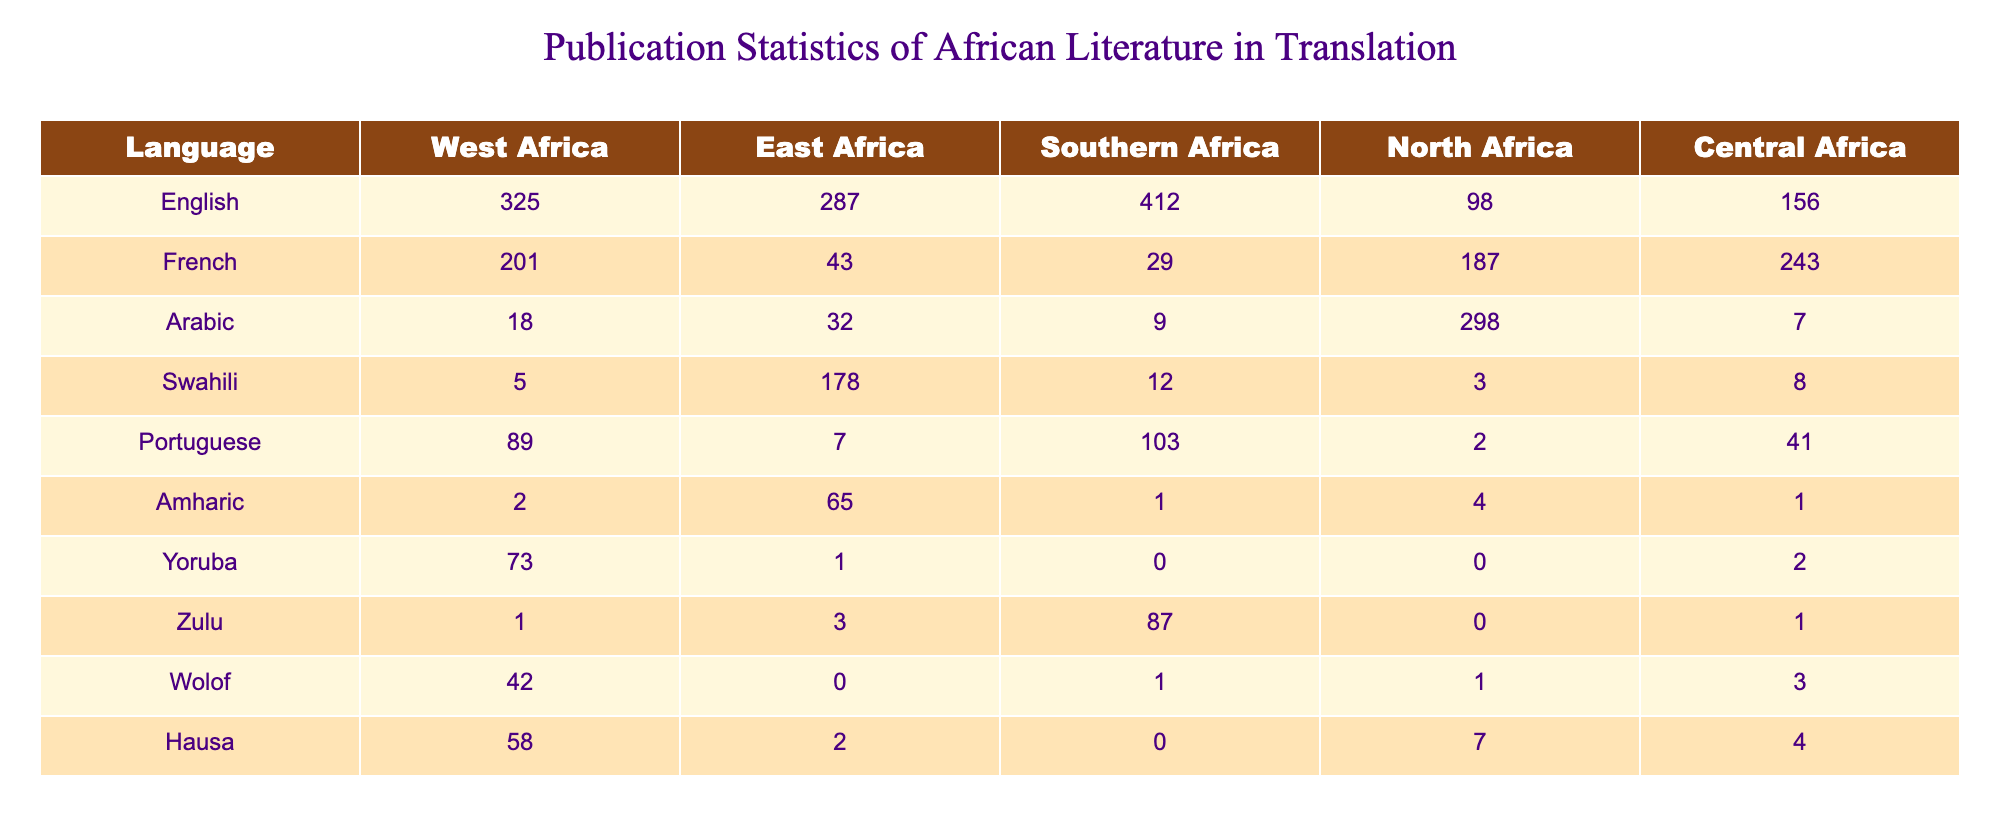What's the total number of publications in English literature from West Africa? The data indicates that the total number of publications in English literature from West Africa is 325, which is directly stated in the table.
Answer: 325 Which language has the highest number of publications in East Africa? By examining the East Africa column, English literature has the highest number with 287 publications, compared to others like Swahili (178) and French (43).
Answer: English Calculate the average number of publications for Arabic literature across all regions. To find the average, add the values from all regions for Arabic (18 + 32 + 9 + 298 + 7 = 364) and divide by the number of regions (5). The average is 364/5 = 72.8.
Answer: 72.8 Is there a higher number of publications in Portuguese literature in Southern Africa than in West Africa? In Southern Africa, there are 103 publications in Portuguese literature, while in West Africa, there are 89. Since 103 is greater than 89, the answer is yes.
Answer: Yes What is the total number of publications in translation for Wolof literature across all regions? The values for Wolof literature across all regions are 42 (West Africa) + 0 (East Africa) + 1 (Southern Africa) + 1 (North Africa) + 3 (Central Africa), which sums up to 47.
Answer: 47 Which region has the least number of publications in Amharic literature? Looking at the Amharic column, we see the values: 2 (West Africa), 65 (East Africa), 1 (Southern Africa), 4 (North Africa), and 1 (Central Africa). The least count is 1, seen in both Southern and Central Africa.
Answer: Southern Africa and Central Africa How many more publications are there in Zulu literature compared to Yoruba literature in Southern Africa? In Southern Africa, there are 87 publications in Zulu literature and 0 in Yoruba literature. The difference is 87 - 0 = 87.
Answer: 87 Is it true that there are more publications in French literature in North Africa than in Central Africa? North Africa has 187 publications in French literature, while Central Africa has 243. Since 187 is less than 243, the statement is false.
Answer: No What is the total for Hausa literature publications in all regions? Summing the counts for Hausa literature across all regions yields 58 (West Africa) + 2 (East Africa) + 0 (Southern Africa) + 7 (North Africa) + 4 (Central Africa) = 71.
Answer: 71 